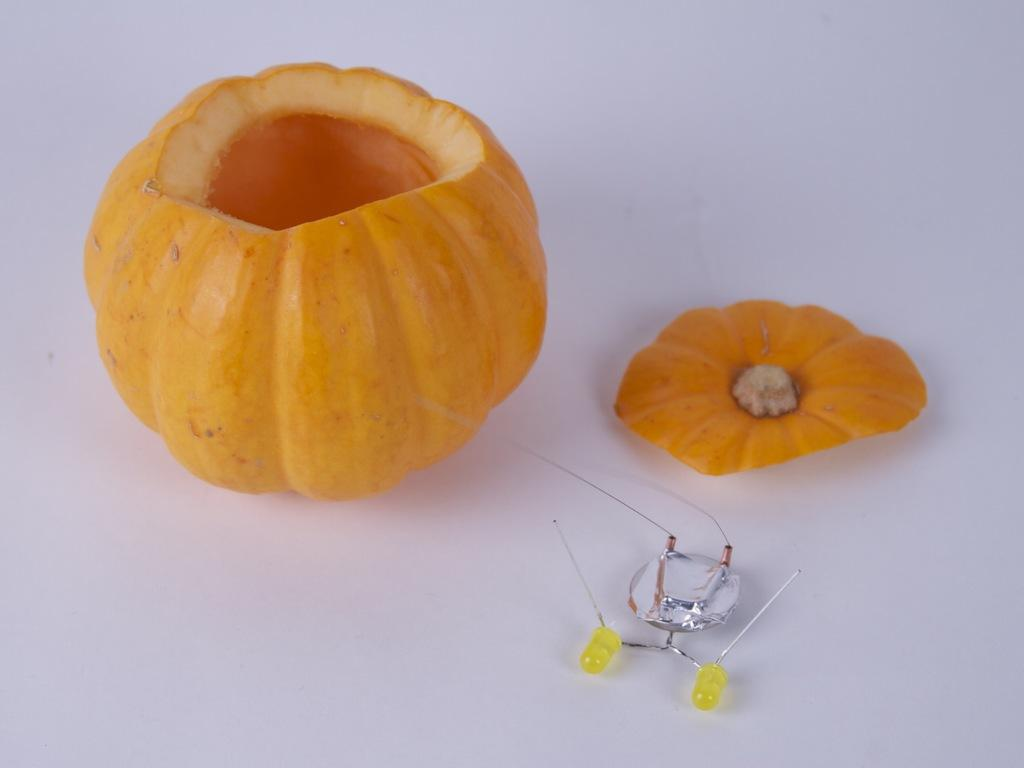What type of food can be seen in the image? There is a fruit in the image. What color is one of the objects in the image? There is an object that is yellow in color. On what surface are the objects placed? The objects are kept on a surface. What color is the surface? The surface is white in color. What direction is the egg moving in the image? There is no egg present in the image, so it cannot be determined if it is moving or in which direction. 